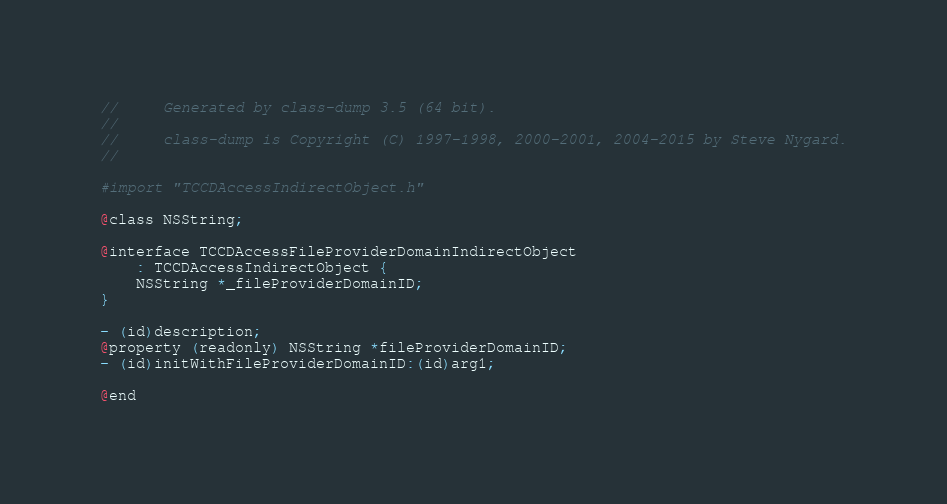Convert code to text. <code><loc_0><loc_0><loc_500><loc_500><_C_>//     Generated by class-dump 3.5 (64 bit).
//
//     class-dump is Copyright (C) 1997-1998, 2000-2001, 2004-2015 by Steve Nygard.
//

#import "TCCDAccessIndirectObject.h"

@class NSString;

@interface TCCDAccessFileProviderDomainIndirectObject
    : TCCDAccessIndirectObject {
    NSString *_fileProviderDomainID;
}

- (id)description;
@property (readonly) NSString *fileProviderDomainID;
- (id)initWithFileProviderDomainID:(id)arg1;

@end
</code> 